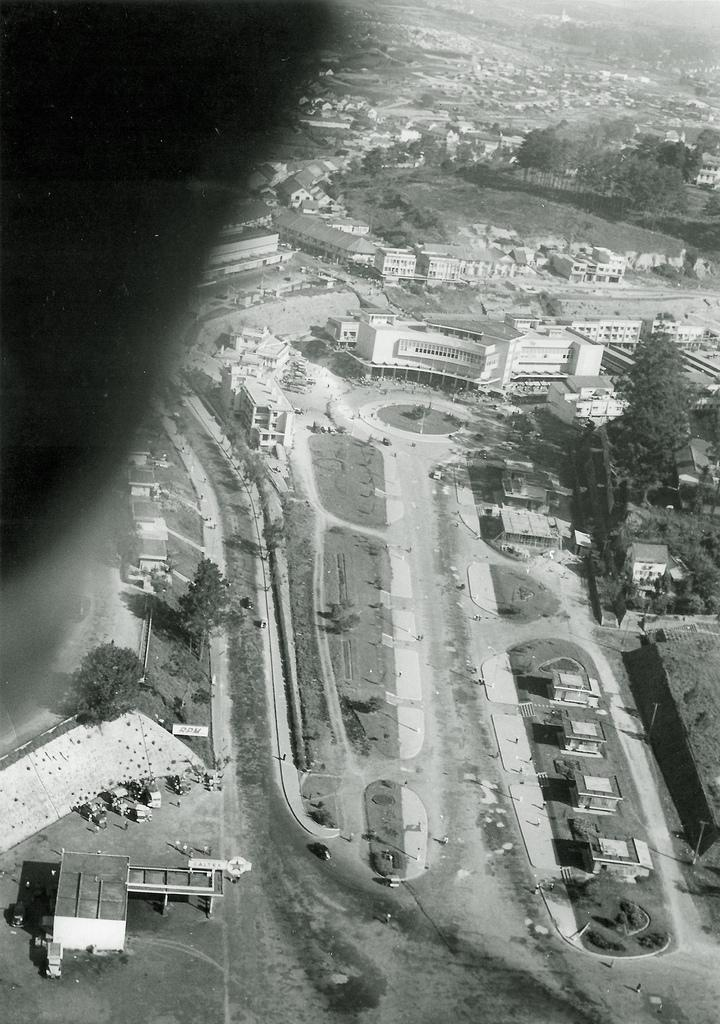What is the color scheme of the image? The image is black and white. What can be seen on the top left of the image? There is an object on the top left of the image. What type of natural environment is visible on the right side of the image? There are trees, roads, buildings, and grass on the right side of the image. Where is the plastic office located in the image? There is no plastic office present in the image. What type of army is depicted in the image? There is no army depicted in the image. 